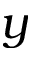<formula> <loc_0><loc_0><loc_500><loc_500>y</formula> 